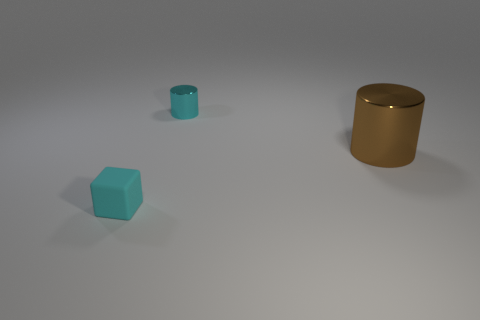Add 1 small cyan cubes. How many objects exist? 4 Subtract all cubes. How many objects are left? 2 Add 2 small shiny objects. How many small shiny objects exist? 3 Subtract 0 gray blocks. How many objects are left? 3 Subtract all small yellow rubber blocks. Subtract all metallic things. How many objects are left? 1 Add 2 tiny cyan cubes. How many tiny cyan cubes are left? 3 